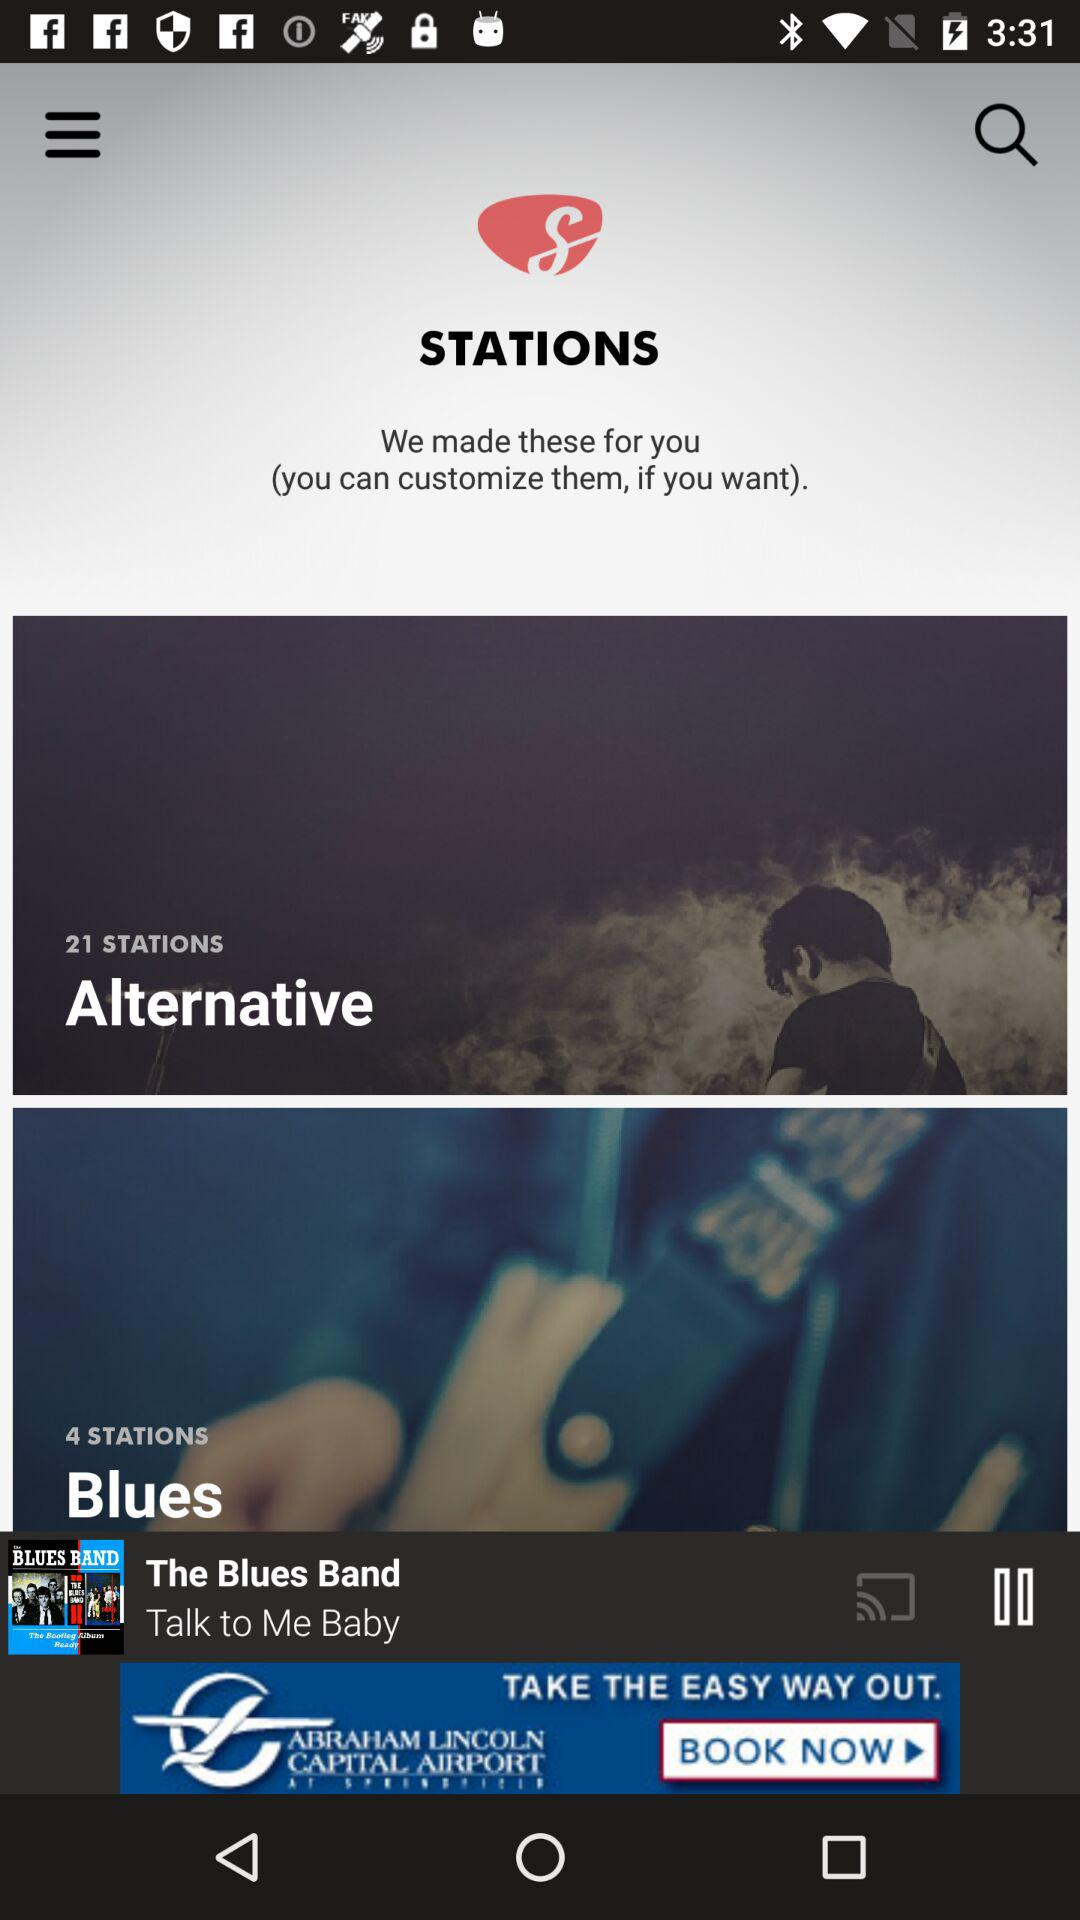How many stations are there in total?
Answer the question using a single word or phrase. 25 